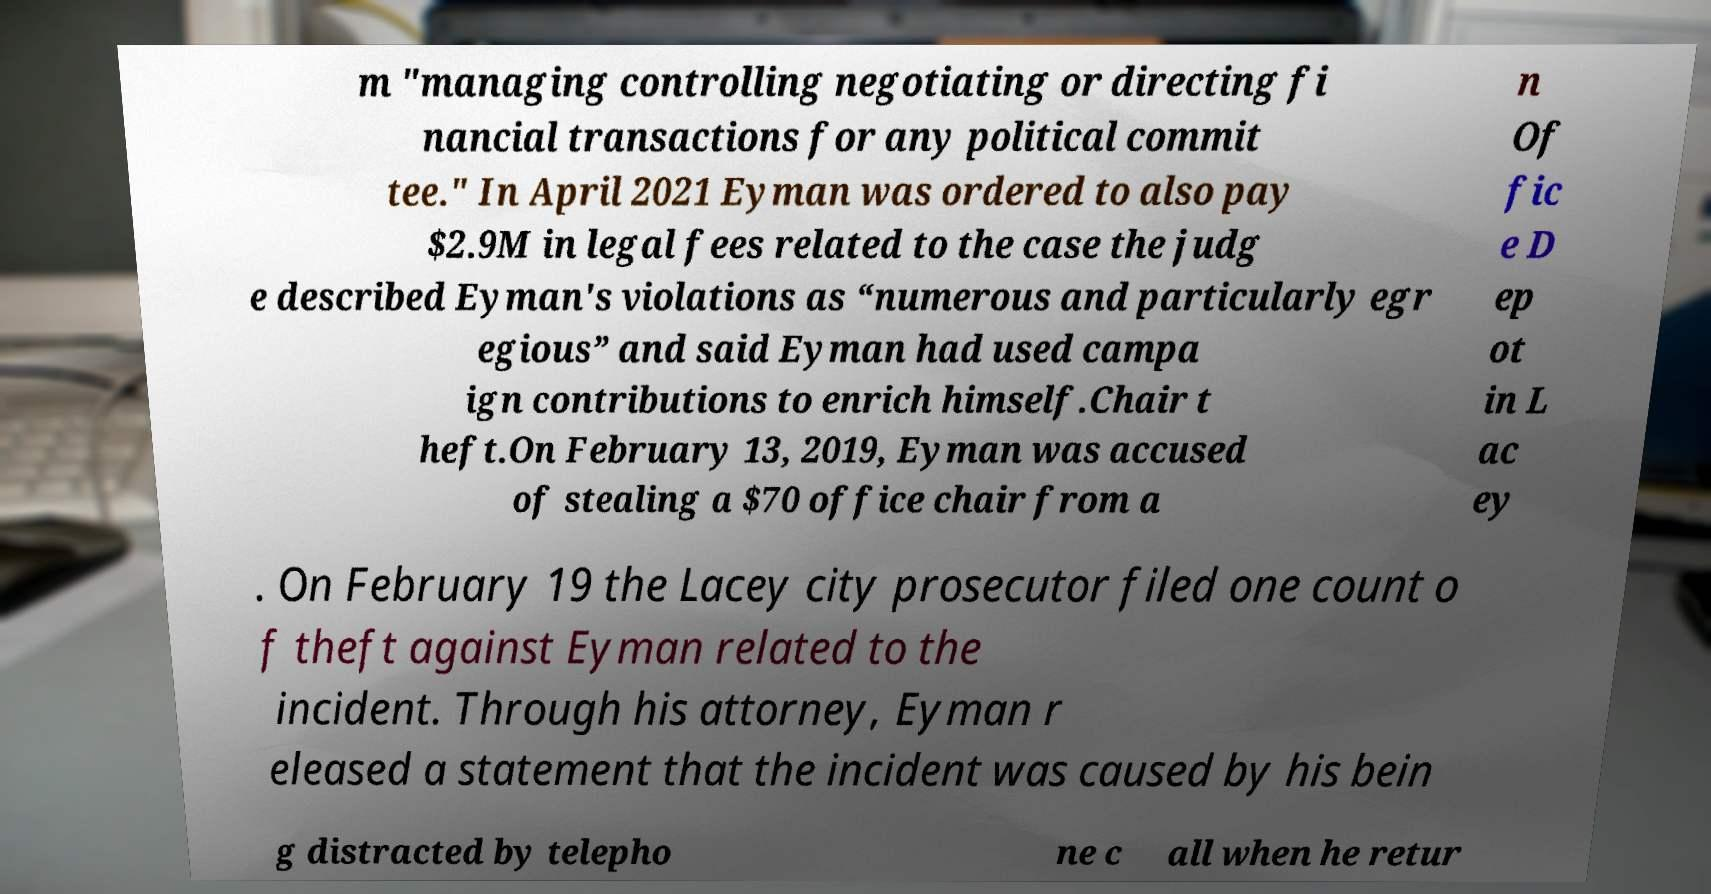Could you assist in decoding the text presented in this image and type it out clearly? m "managing controlling negotiating or directing fi nancial transactions for any political commit tee." In April 2021 Eyman was ordered to also pay $2.9M in legal fees related to the case the judg e described Eyman's violations as “numerous and particularly egr egious” and said Eyman had used campa ign contributions to enrich himself.Chair t heft.On February 13, 2019, Eyman was accused of stealing a $70 office chair from a n Of fic e D ep ot in L ac ey . On February 19 the Lacey city prosecutor filed one count o f theft against Eyman related to the incident. Through his attorney, Eyman r eleased a statement that the incident was caused by his bein g distracted by telepho ne c all when he retur 